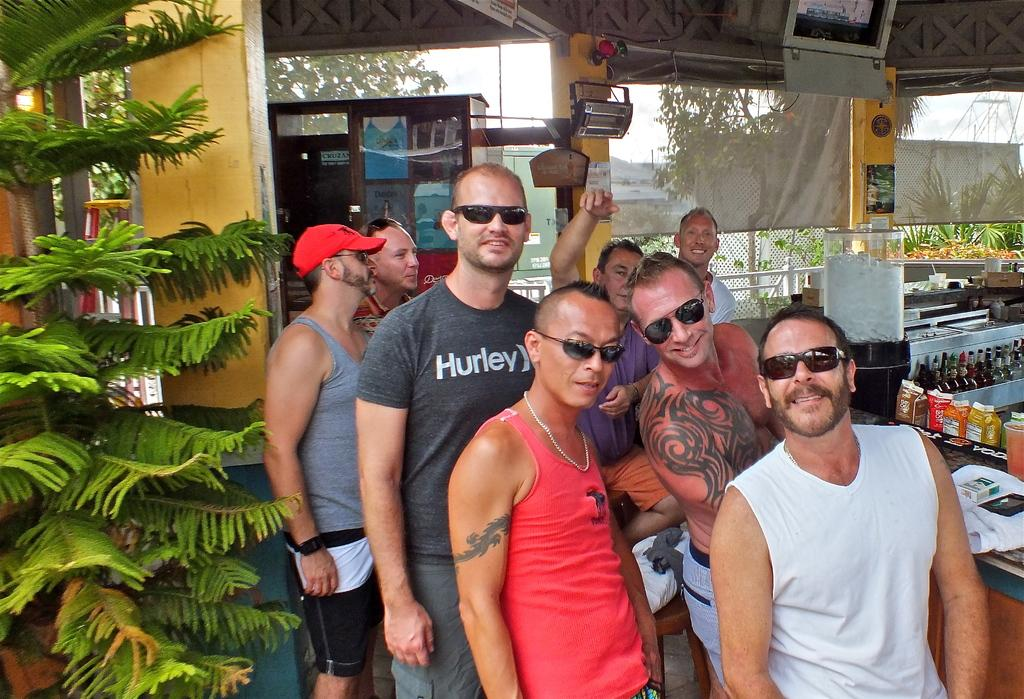How many people are in the image? There is a group of people in the image. Where are the people located? The people are in a wine store. What can be seen in the wine store besides the people? There are wine bottles in the image. What is visible outside the wine store? There is a tree visible in the image. What type of art can be seen on the wine bottles in the image? There is no mention of art on the wine bottles in the image; the focus is on the presence of the bottles themselves. 